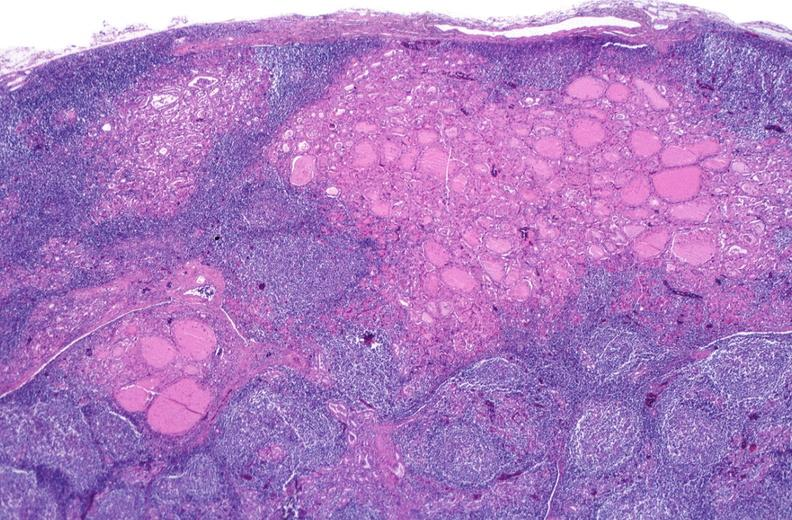what does this image show?
Answer the question using a single word or phrase. Hashimoto 's thyroiditis 